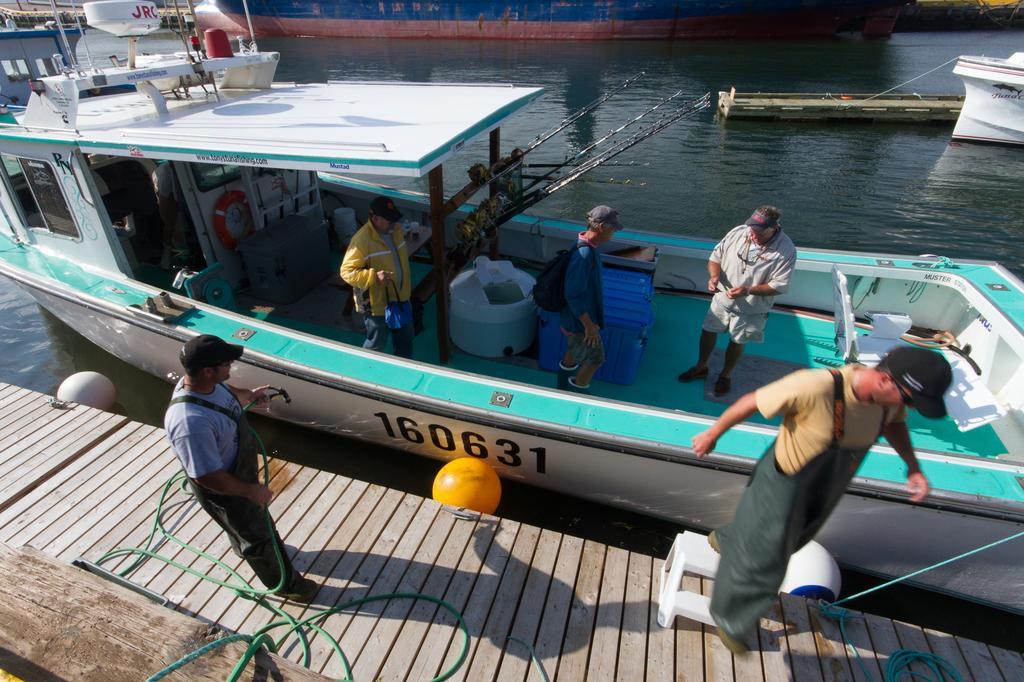Can you describe this image briefly? In this picture I can see the wooden platform, on which I can see 2 men and I see that, the man on the left is holding a green color thing. In the background I can see the water, on which there are few boats and on the front boat, I can see 3 men standing. 